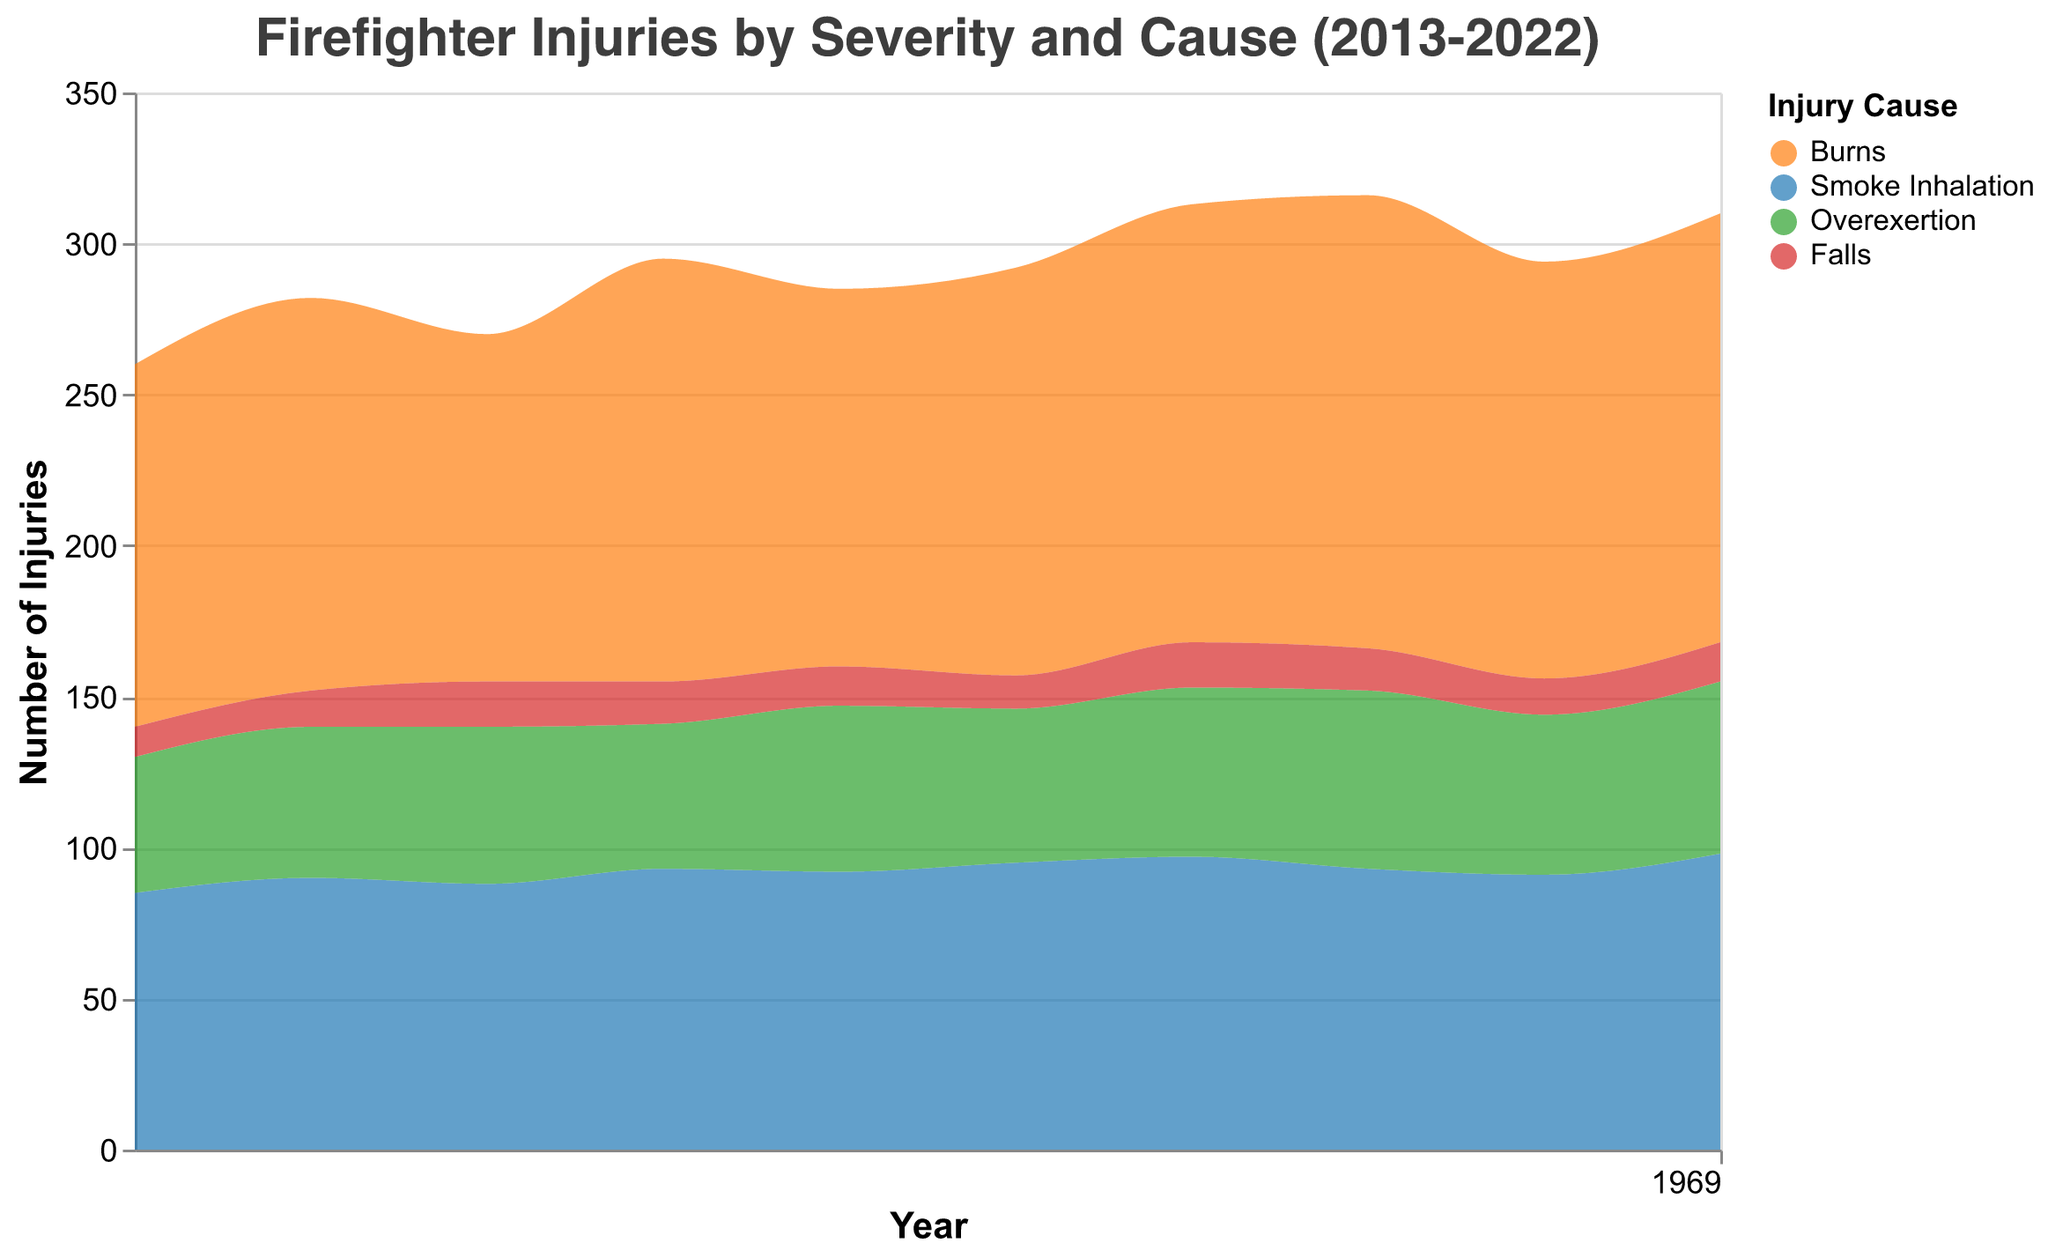What is the title of the figure? The title is located at the top of the figure and it reads "Firefighter Injuries by Severity and Cause (2013-2022)."
Answer: Firefighter Injuries by Severity and Cause (2013-2022) Which cause of injury has the highest number of injuries in 2022? By looking at the area shared among different causes of injuries in 2022, it's evident that "Burns" has the highest number. Burns' area is the largest for that year.
Answer: Burns How many total injuries occurred due to falls in 2015? Falling under the "Severe" category, the point for Falls in 2015 reveals that there were 15 injuries.
Answer: 15 What trend can you observe for minor injuries caused by burns from 2013 to 2022? Observing the area for "Minor" injuries due to burns, it generally shows an increasing trend from 2013 (120 injuries) to 2022 (142 injuries).
Answer: Increasing Which year had the highest number of injuries due to smoke inhalation? Checking the height of the area for the cause "Smoke Inhalation," the year with the highest number of injuries is 2022 with 98 injuries.
Answer: 2022 What is the total number of moderate injuries due to overexertion in 2019 and 2020? In 2019, overexertion caused 56 moderate injuries and in 2020, it caused 59. Summing these, 56 + 59 gives 115 total injuries.
Answer: 115 Which cause of injury shows the least variation in the number of severe injuries over the decade? By comparing the changing heights of "Severe" injuries due to different causes, "Falls" appears to show the least variation. The number stays between 10 and 15 injuries each year.
Answer: Falls How did the number of minor injuries from burns change from 2016 to 2020? Starting at 140 in 2016, the numbers gradually increased each year, hitting 150 by 2020.
Answer: Increased Which severity level and cause contribute the least to the total number of injuries in any given year? The smallest area on the chart, in any given year, is "Severe" injuries due to "Falls," especially visible in years like 2013 and 2018.
Answer: Severe Falls What has been the general trend in the number of injuries caused by overexertion over the last decade? Observing the area pertaining to overexertion of any severity, it's noted that there is a slight increasing trend overall from 2013 to 2022.
Answer: Increasing 